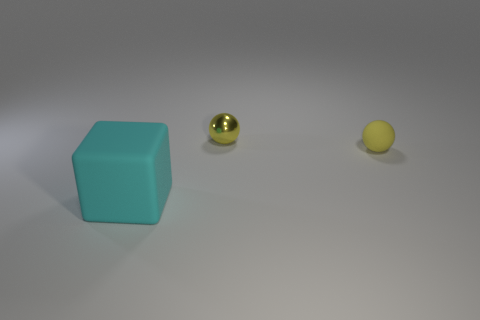There is another sphere that is the same color as the small metal sphere; what material is it?
Make the answer very short. Rubber. Is there anything else that has the same shape as the cyan object?
Provide a short and direct response. No. What is the material of the large cyan block on the left side of the small rubber thing?
Provide a short and direct response. Rubber. Are there any other things that have the same size as the yellow shiny thing?
Offer a terse response. Yes. There is a yellow metal thing; are there any yellow things in front of it?
Keep it short and to the point. Yes. What is the shape of the small shiny object?
Ensure brevity in your answer.  Sphere. How many things are either rubber things that are behind the cyan matte object or small shiny spheres?
Keep it short and to the point. 2. How many other objects are the same color as the small metal sphere?
Your response must be concise. 1. There is a rubber sphere; does it have the same color as the object to the left of the yellow metal ball?
Your response must be concise. No. There is a metal thing that is the same shape as the tiny rubber thing; what color is it?
Your answer should be compact. Yellow. 